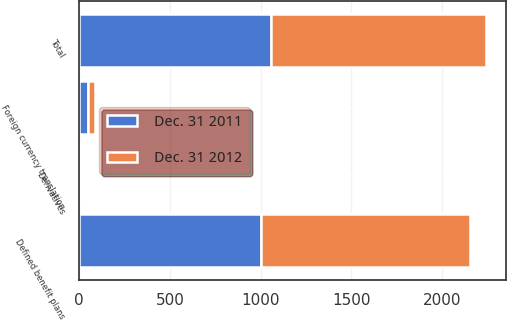Convert chart. <chart><loc_0><loc_0><loc_500><loc_500><stacked_bar_chart><ecel><fcel>Defined benefit plans<fcel>Foreign currency translation<fcel>Derivatives<fcel>Total<nl><fcel>Dec. 31 2012<fcel>1149<fcel>36<fcel>1<fcel>1186<nl><fcel>Dec. 31 2011<fcel>1004<fcel>48<fcel>2<fcel>1054<nl></chart> 